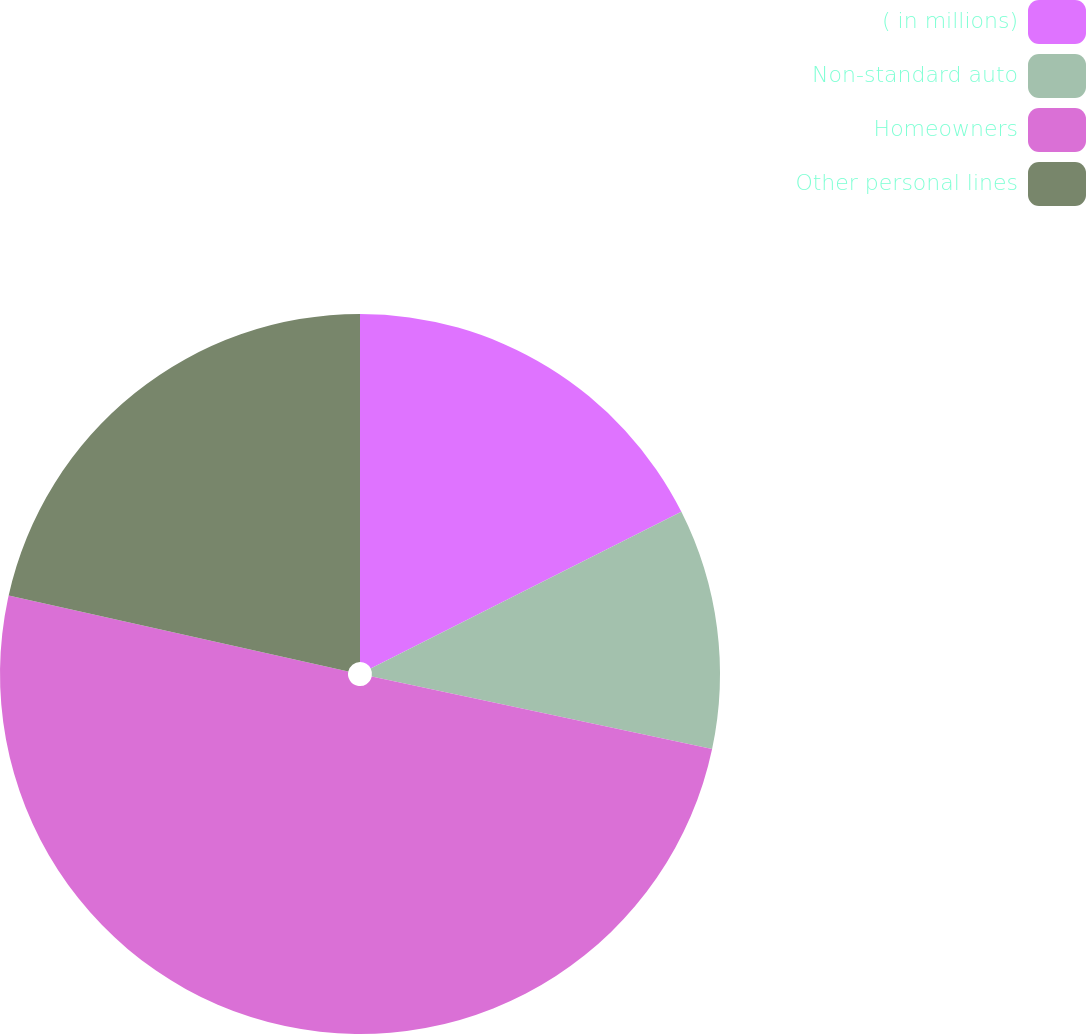Convert chart to OTSL. <chart><loc_0><loc_0><loc_500><loc_500><pie_chart><fcel>( in millions)<fcel>Non-standard auto<fcel>Homeowners<fcel>Other personal lines<nl><fcel>17.56%<fcel>10.78%<fcel>50.16%<fcel>21.5%<nl></chart> 